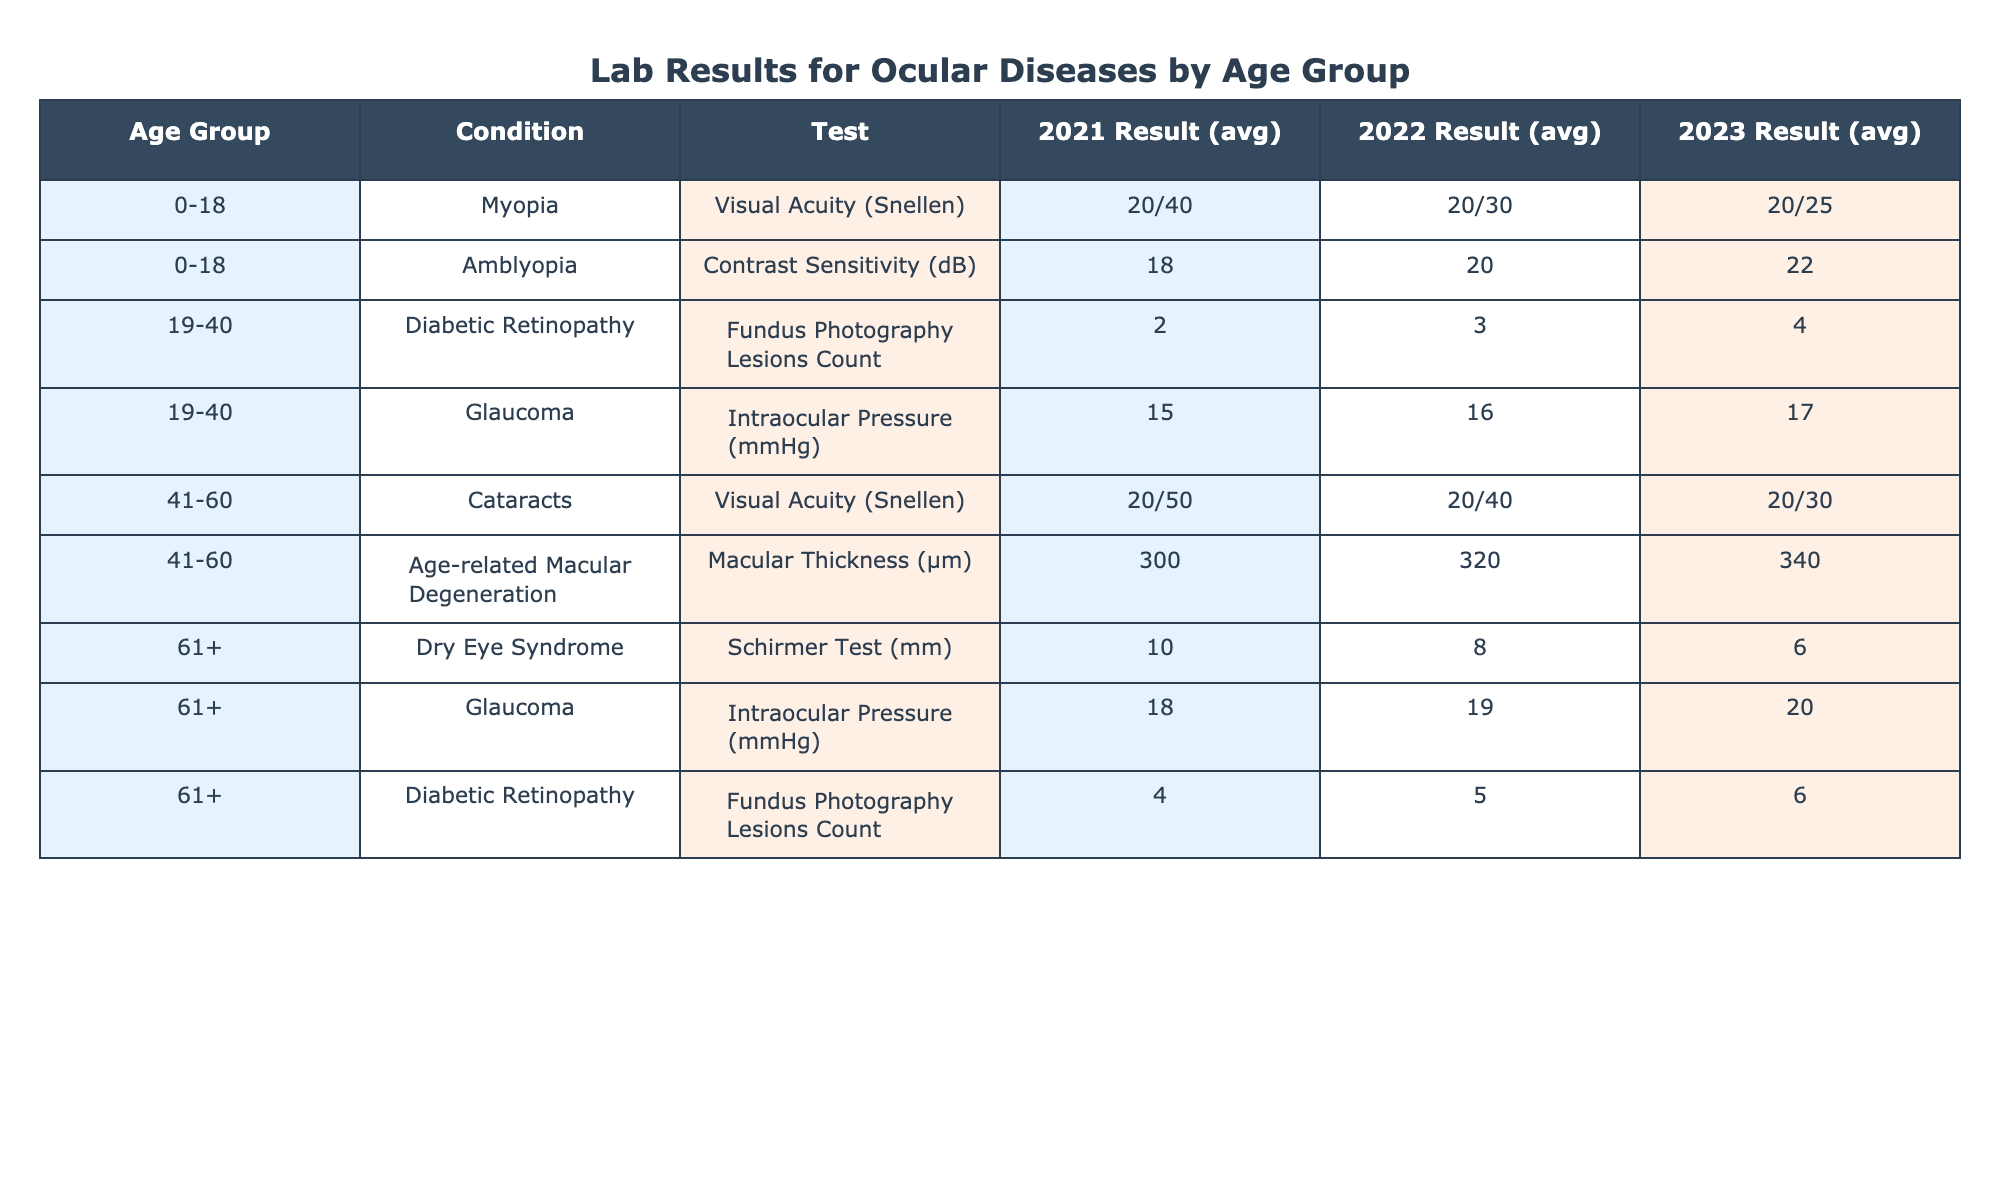What was the average result for Visual Acuity in the age group 41-60 from 2021 to 2023? For the age group 41-60, the Visual Acuity results from 2021 to 2023 are 20/50, 20/40, and 20/30. This averages out to the middle value, which is 20/40, as there are three results.
Answer: 20/40 Did the average Intraocular Pressure for Glaucoma in the 61+ age group increase over the years? In the 61+ age group, the Intraocular Pressure for Glaucoma began at 18 mmHg in 2021, then increased to 19 mmHg in 2022, and further increased to 20 mmHg in 2023. This indicates a consistent increase over the years.
Answer: Yes What is the difference in average Contrast Sensitivity (dB) results for Amblyopia between 2021 and 2023 for the 0-18 age group? The Contrast Sensitivity result for Amblyopia in the 0-18 age group was 18 dB in 2021 and increased to 22 dB in 2023. Thus, the difference is 22 - 18 = 4 dB.
Answer: 4 dB What was the maximum count of Fundus Photography Lesions recorded across all age groups in 2023? In 2023, the recorded counts of Fundus Photography Lesions are 4 (19-40 age group) and 6 (61+ age group). The maximum count is 6, which comes from the 61+ age group.
Answer: 6 Is it true that the average Visual Acuity (Snellen) result improved from 2021 to 2023 for the age group 0-18? The Visual Acuity results for the 0-18 age group improved from 20/40 in 2021 to 20/25 in 2023. Improvement is indicated by the reduction in the fraction, confirming the statement.
Answer: Yes What was the change in average Macular Thickness (µm) for Age-related Macular Degeneration in the 41-60 age group from 2021 to 2023? The average Macular Thickness was 300 µm in 2021 and increased to 340 µm in 2023. The change is 340 - 300 = 40 µm, indicating a significant increase over the period.
Answer: 40 µm Which condition had the lowest overall average result in the table for the year 2022? Assessing all the average results for 2022, the lowest is from the Dry Eye Syndrome (Schirmer Test) at 8 mm, indicating it had the least favorable outcome compared to others.
Answer: 8 mm Did the average results for Diabetic Retinopathy consistently rise over 2021, 2022, and 2023 in the 19-40 age group? The average results for Diabetic Retinopathy were 2 in 2021, increased to 3 in 2022, and continued to increase to 4 in 2023. Each subsequent year shows a rise, confirming the consistency.
Answer: Yes 